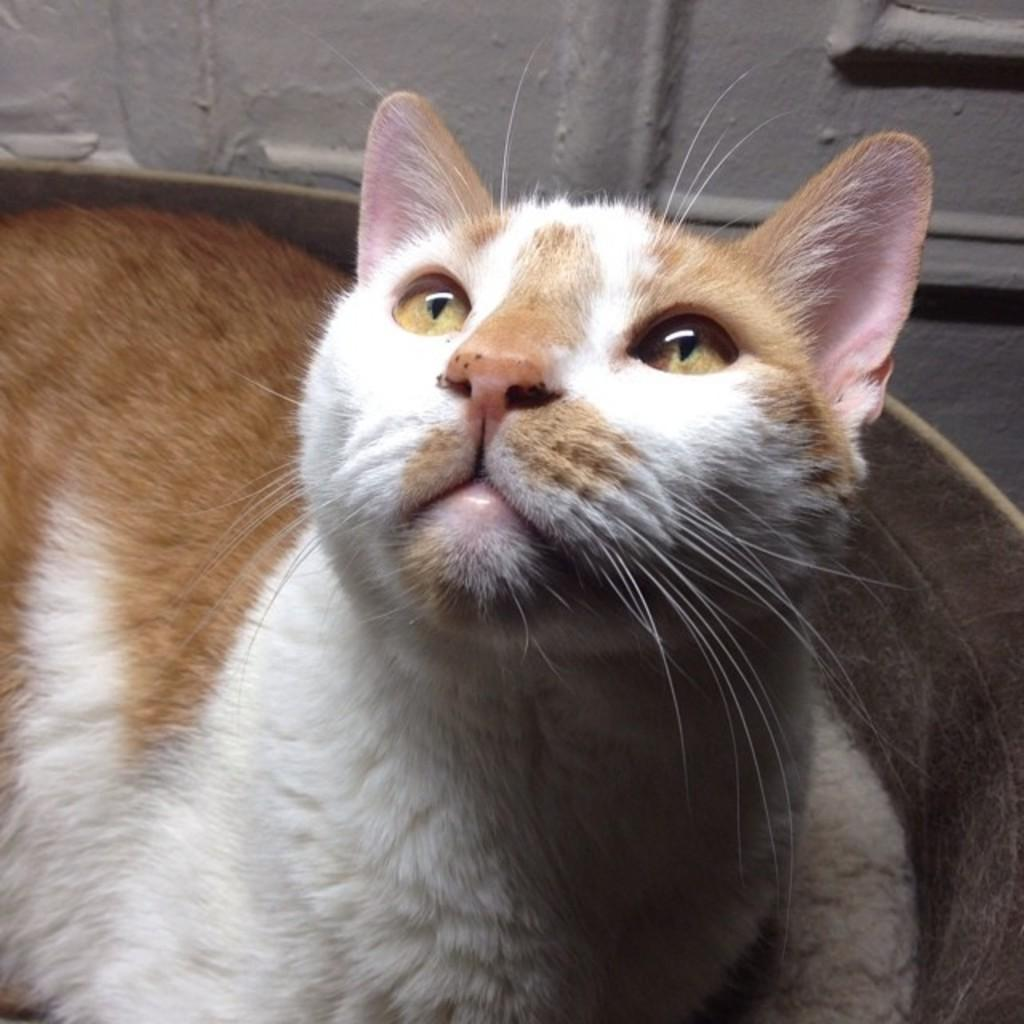What type of animal is in the image? There is a cat in the image. What is the cat doing in the image? The cat is looking upwards. What type of twig is the cat holding in the image? There is no twig present in the image; the cat is simply looking upwards. 